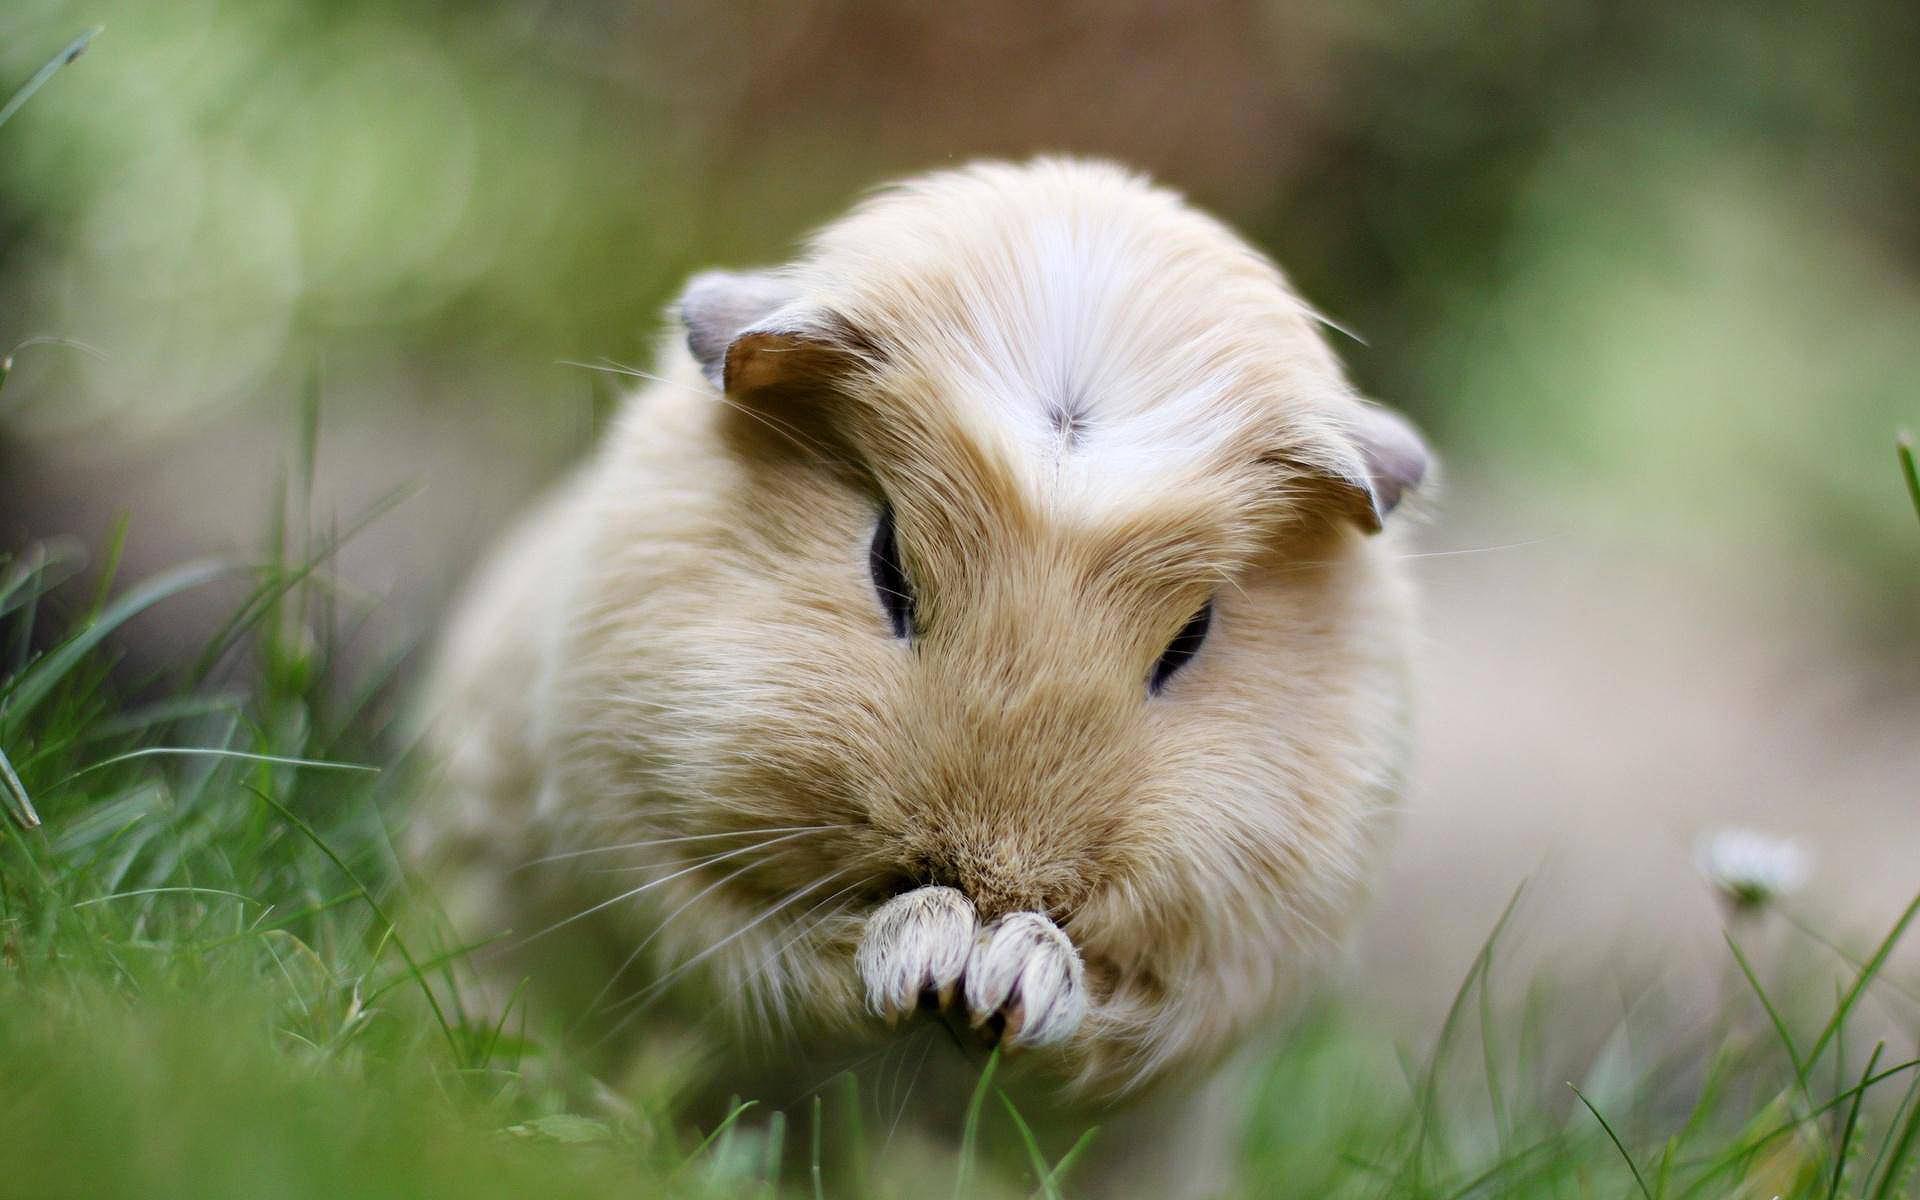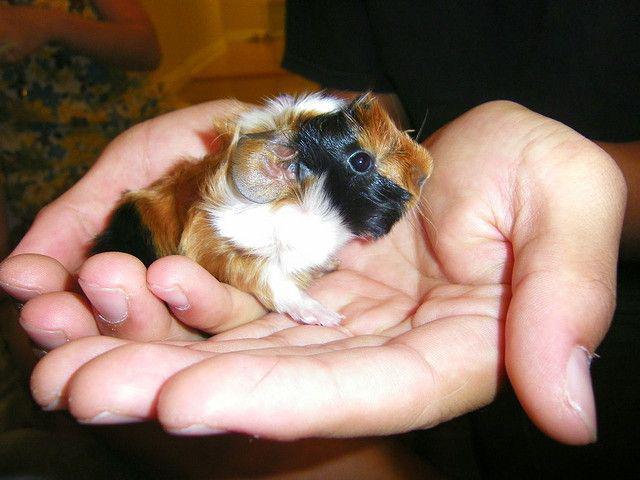The first image is the image on the left, the second image is the image on the right. For the images displayed, is the sentence "there are numerous guinea pigs housed in a concrete pen" factually correct? Answer yes or no. No. 